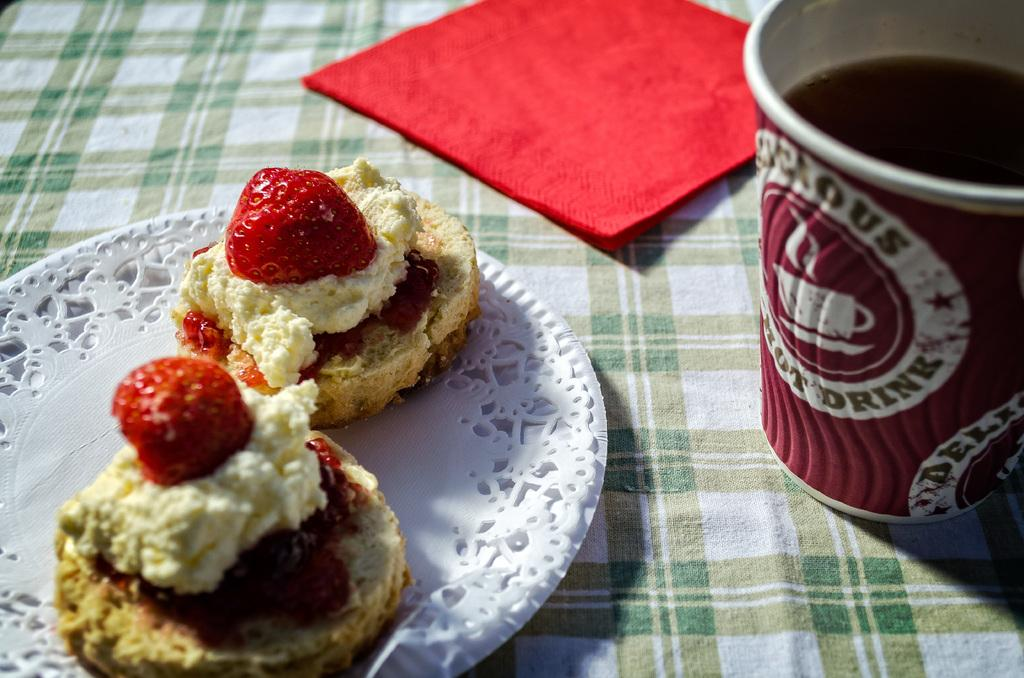What is located at the bottom of the image? There is a cloth at the bottom of the image. What else can be seen in the image besides the cloth? There is a plate and a glass of drink in the image. What color is the cloth present in the image? There is a red color cloth present in the image. What is on the plate in the image? There is food in the plate. What type of coal is being used by the committee in the image? There is no committee or coal present in the image. What is the hope of the person in the image? There is no person or hope mentioned in the image; it only shows a cloth, a plate, a glass of drink, and food. 